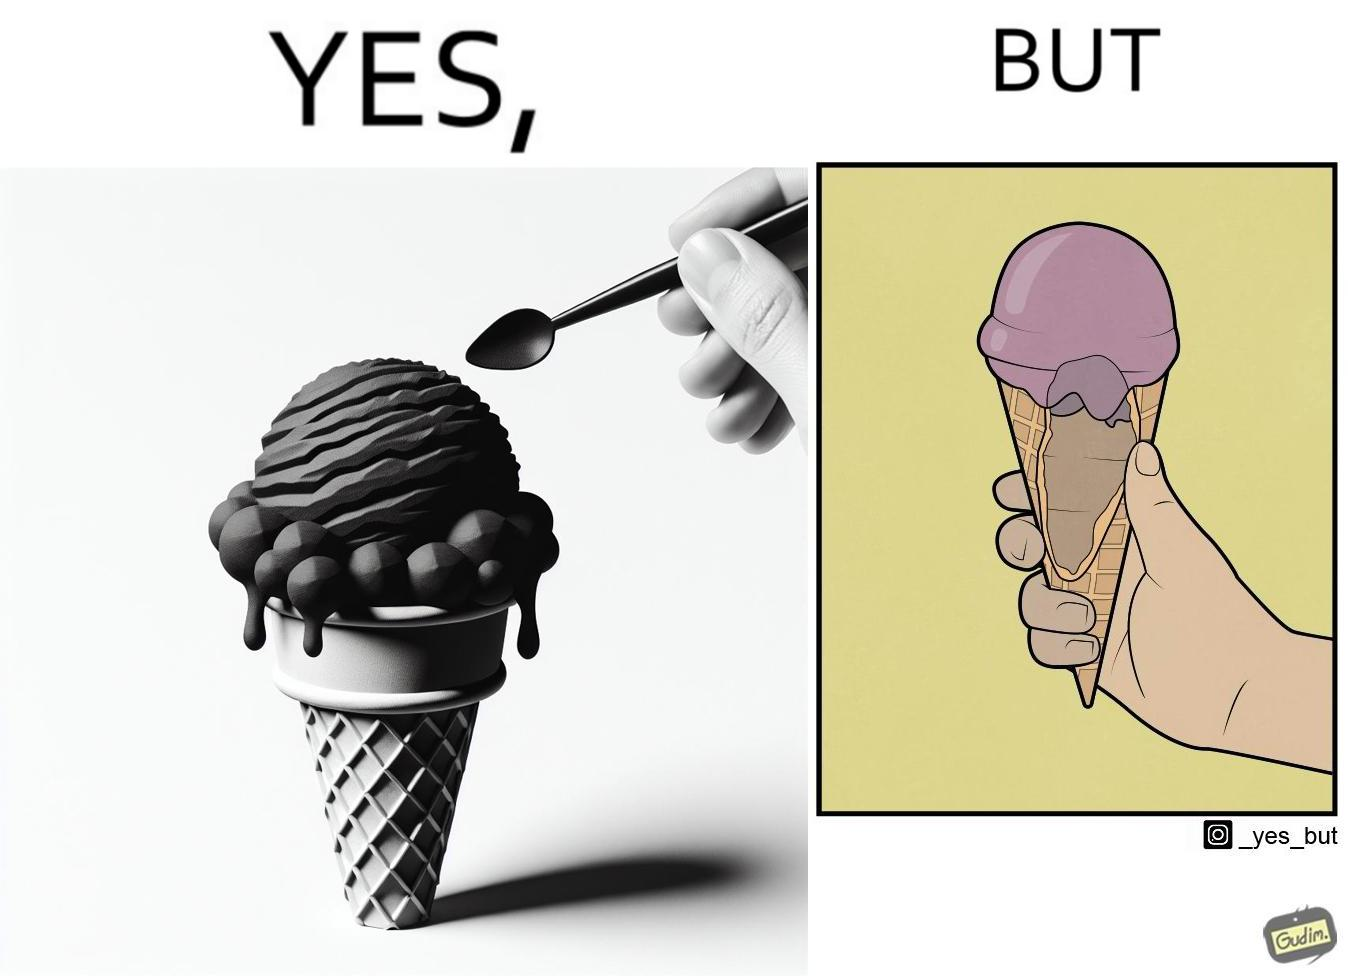Explain the humor or irony in this image. The image is ironic, because in one image the softy cone is shown filled with softy but in second image it is visible that only the top of the cone is filled and at the inside the cone is vacant 